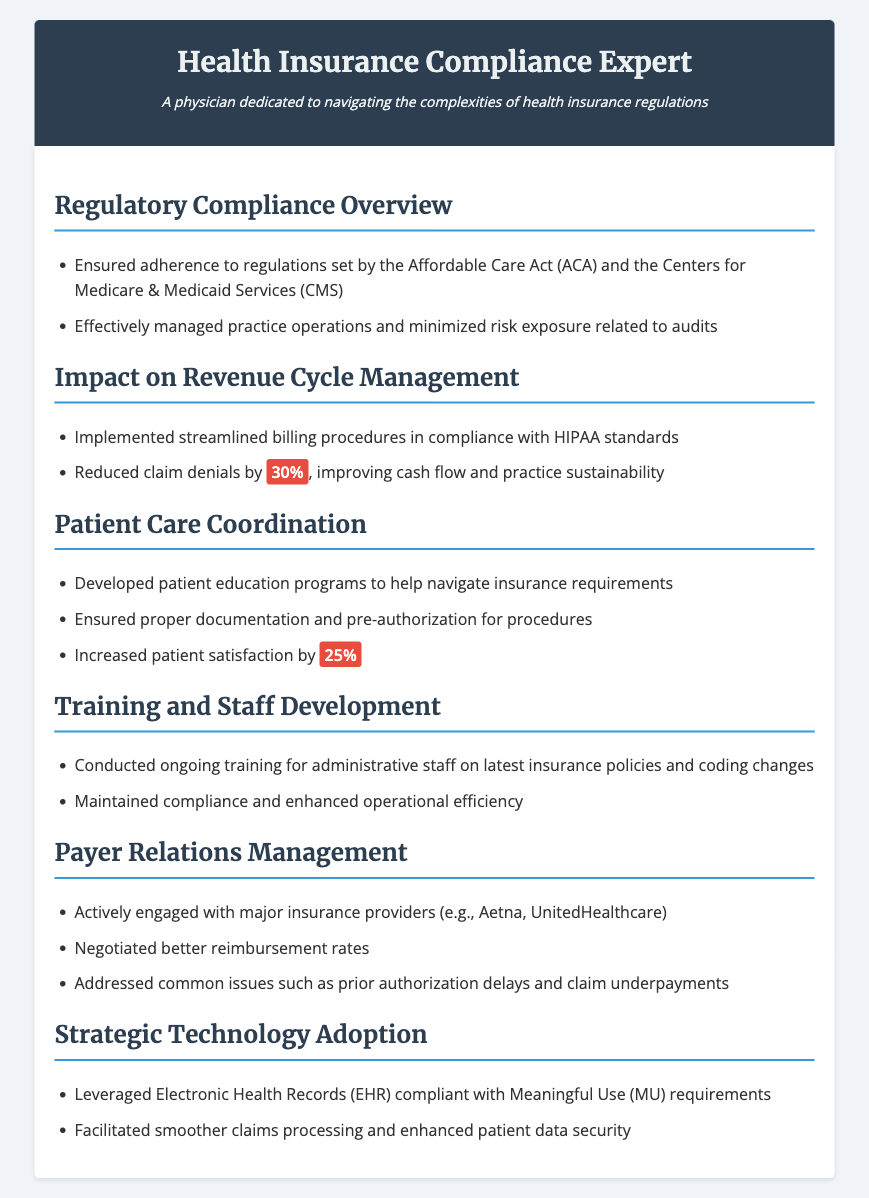what act is mentioned for regulatory compliance? The document refers to the Affordable Care Act (ACA) as a key regulation for compliance in the healthcare setting.
Answer: Affordable Care Act (ACA) what was the percentage reduction in claim denials? The document states that claim denials were reduced by 30%, indicating improved collection processes.
Answer: 30% what was the increase in patient satisfaction? The document highlights that patient satisfaction increased by 25% as a result of educational programs and proper documentation.
Answer: 25% which major insurance providers were engaged with? The document lists major insurance providers like Aetna and UnitedHealthcare that were actively engaged in payer relations management.
Answer: Aetna, UnitedHealthcare what is the purpose of ongoing staff training? The document specifies that ongoing training for administrative staff ensures compliance and enhances operational efficiency.
Answer: Compliance and operational efficiency how did electronic health records contribute to operations? The electronic health records facilitated smoother claims processing and enhanced patient data security, according to the document.
Answer: Smoother claims processing and enhanced patient data security what regulatory agency is mentioned alongside ACA? The Centers for Medicare & Medicaid Services (CMS) is mentioned alongside the Affordable Care Act for regulatory compliance.
Answer: Centers for Medicare & Medicaid Services (CMS) what is highlighted as a strategic technology adoption? The document points out the adoption of Electronic Health Records (EHR) as a strategic technology that meets specific compliance requirements.
Answer: Electronic Health Records (EHR) 